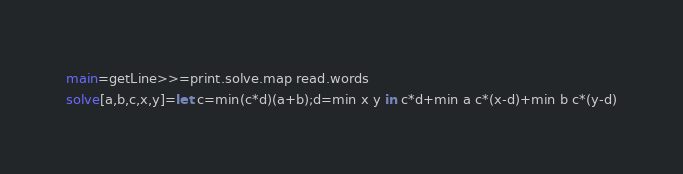<code> <loc_0><loc_0><loc_500><loc_500><_Haskell_>main=getLine>>=print.solve.map read.words
solve[a,b,c,x,y]=let c=min(c*d)(a+b);d=min x y in c*d+min a c*(x-d)+min b c*(y-d)</code> 